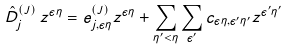Convert formula to latex. <formula><loc_0><loc_0><loc_500><loc_500>\hat { D } _ { j } ^ { ( J ) } \, z ^ { \epsilon \eta } = e _ { j , \epsilon \eta } ^ { ( J ) } z ^ { \epsilon \eta } + \sum _ { \eta ^ { \prime } < \eta } \sum _ { \epsilon ^ { \prime } } c _ { \epsilon \eta , \epsilon ^ { \prime } \eta ^ { \prime } } z ^ { \epsilon ^ { \prime } \eta ^ { \prime } }</formula> 